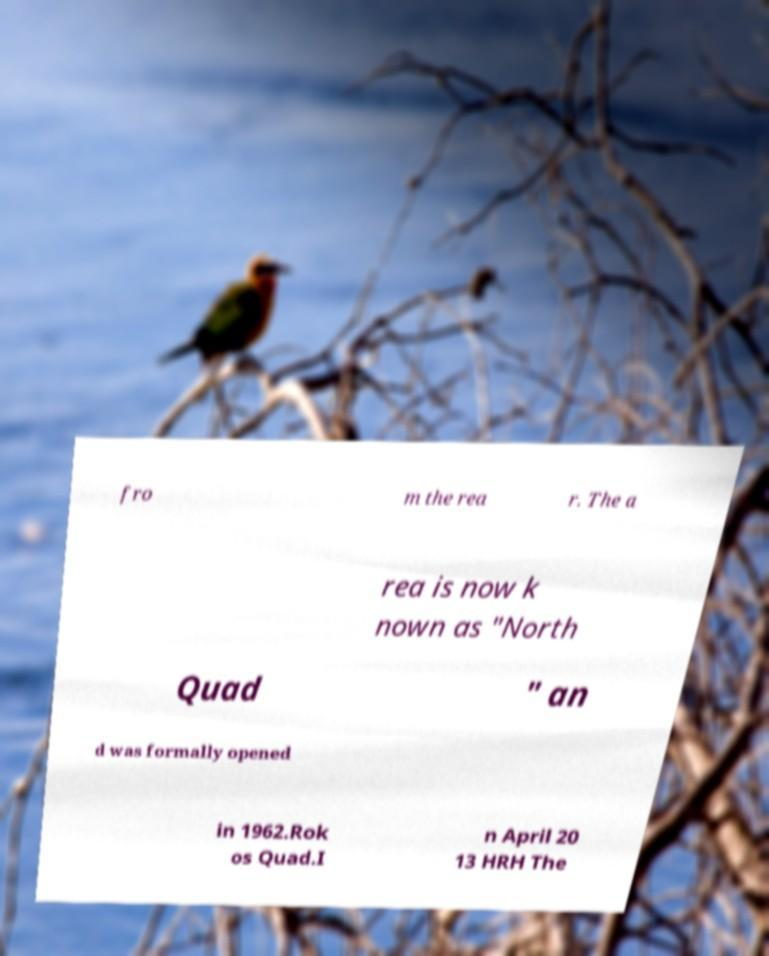Please identify and transcribe the text found in this image. fro m the rea r. The a rea is now k nown as "North Quad " an d was formally opened in 1962.Rok os Quad.I n April 20 13 HRH The 